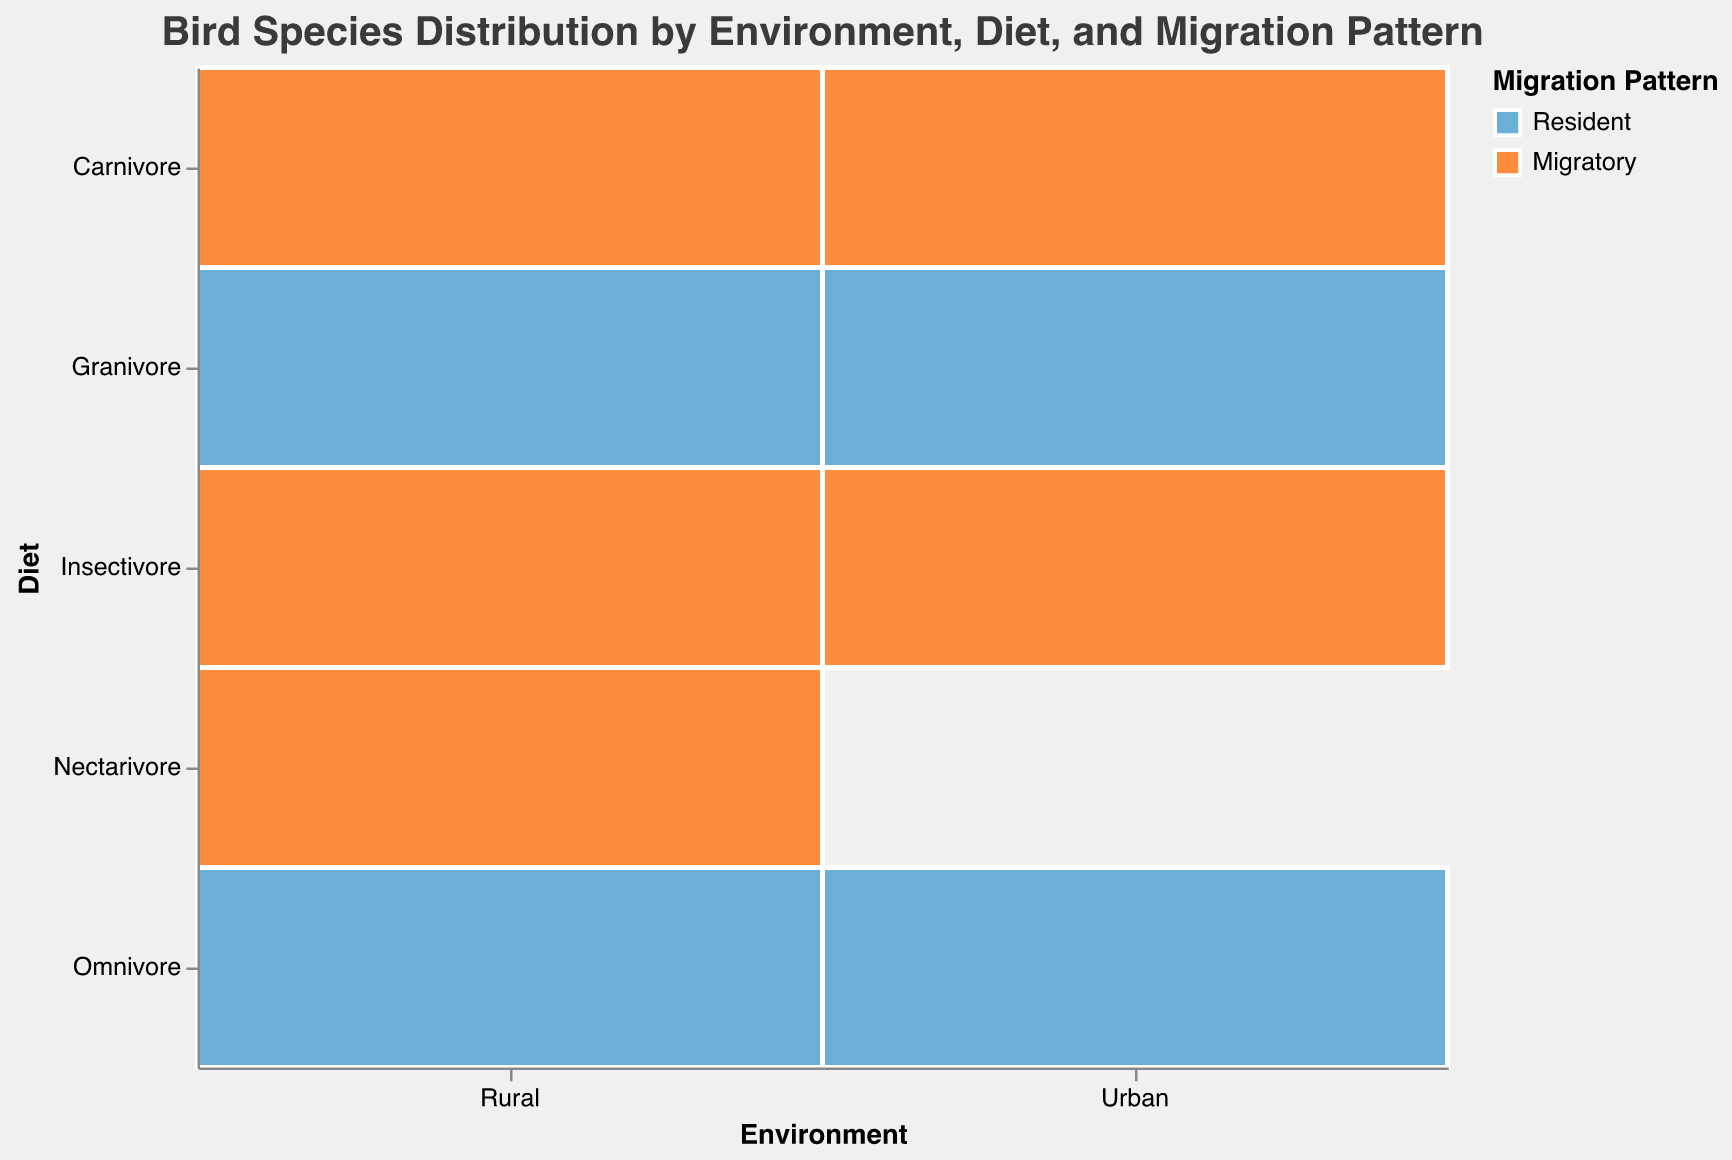What is the title of the mosaic plot? The title of the mosaic plot can be seen at the top of the figure.
Answer: Bird Species Distribution by Environment, Diet, and Migration Pattern How many bird species are present in the data? Each rectangle in the mosaic plot represents a different bird species. Counting them will give the total number of species.
Answer: 10 Which environment has the highest count of birds for the Granivore diet? By looking at the width of the rectangles in the Urban and Rural sections for the Granivore diet, we can compare their sizes. The environment with the larger rectangle for Granivores has the highest count.
Answer: Urban What is the total count of insectivorous birds in rural areas? In the Rural section, insectivorous birds include Eastern Bluebird (count 45). Summing up the counts for these birds will give the total count of insectivorous birds in rural areas.
Answer: 45 Which migratory pattern has more species in urban environments? By checking the color of rectangles in the Urban section, we can compare the number of "Resident" (blue) versus "Migratory" (orange) species.
Answer: Resident How does the occurrence of omnivorous birds in urban environments compare to rural environments? By looking at the sizes of the rectangles for omnivorous birds in Urban and Rural sections, we can compare their counts. Urban omnivores: European Starling (120) + House Sparrow (95) = 215. Rural omnivores: American Crow (70).
Answer: Urban has more omnivores What is the combined count of migratory birds in urban environments? We sum up the counts of migratory birds in the Urban section: Peregrine Falcon (15) + Barn Swallow (80).
Answer: 95 Are there more resident or migratory birds in rural environments? By visually comparing the size of "Resident" (blue) versus "Migratory" (orange) rectangles in the Rural section, we can determine which has more birds.
Answer: Migratory For the diet of Omnivore, which environment has a higher count of birds? By comparing the sizes of the rectangles in the Urban and Rural sections for Omnivore diet, we can determine the environment with the higher count.
Answer: Urban What is the count difference between resident Granivore birds in urban and rural environments? We look at the counts for Granivore birds in both Urban (Rock Pigeon, 150) and Rural (Northern Cardinal, 60) sections and calculate the difference: 150 - 60.
Answer: 90 